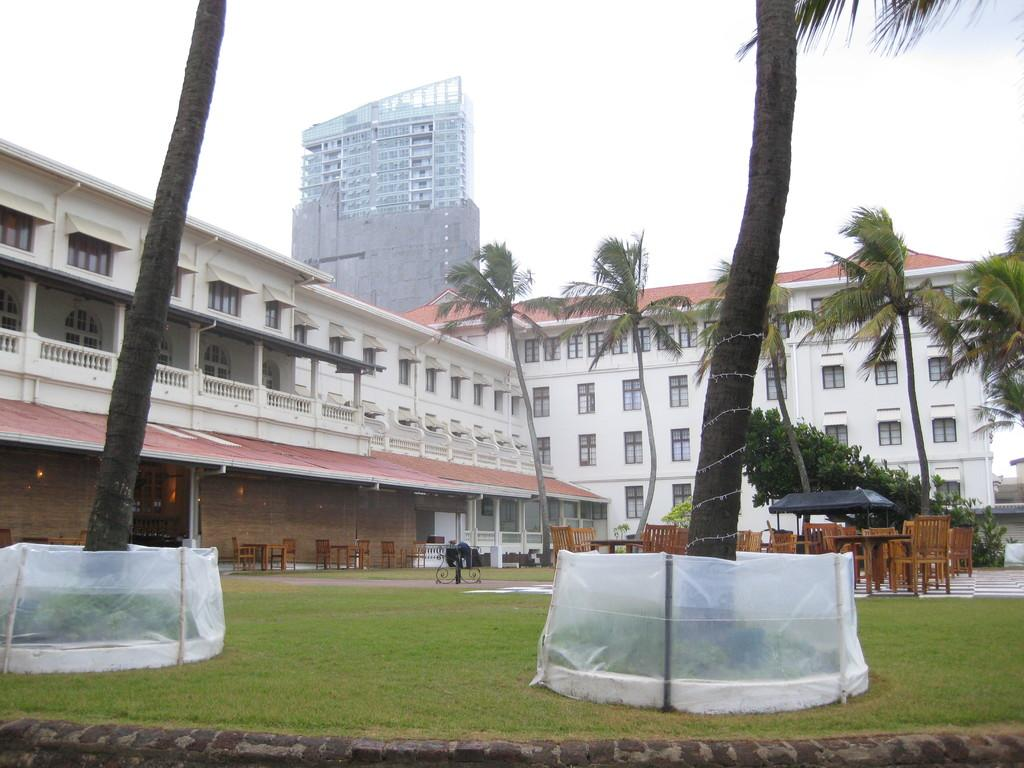What type of furniture is present in the image? There are tables and chairs in the image. What can be seen above the tables and chairs? There are lights in the image. What is visible in the background of the image? There are buildings, trees, and the sky in the background of the image. Can you tell me who won the argument in the image? There is no argument present in the image; it features tables, chairs, lights, and a background with buildings, trees, and the sky. What type of hair can be seen on the chairs in the image? There is no hair visible on the chairs in the image; they are simply chairs. 